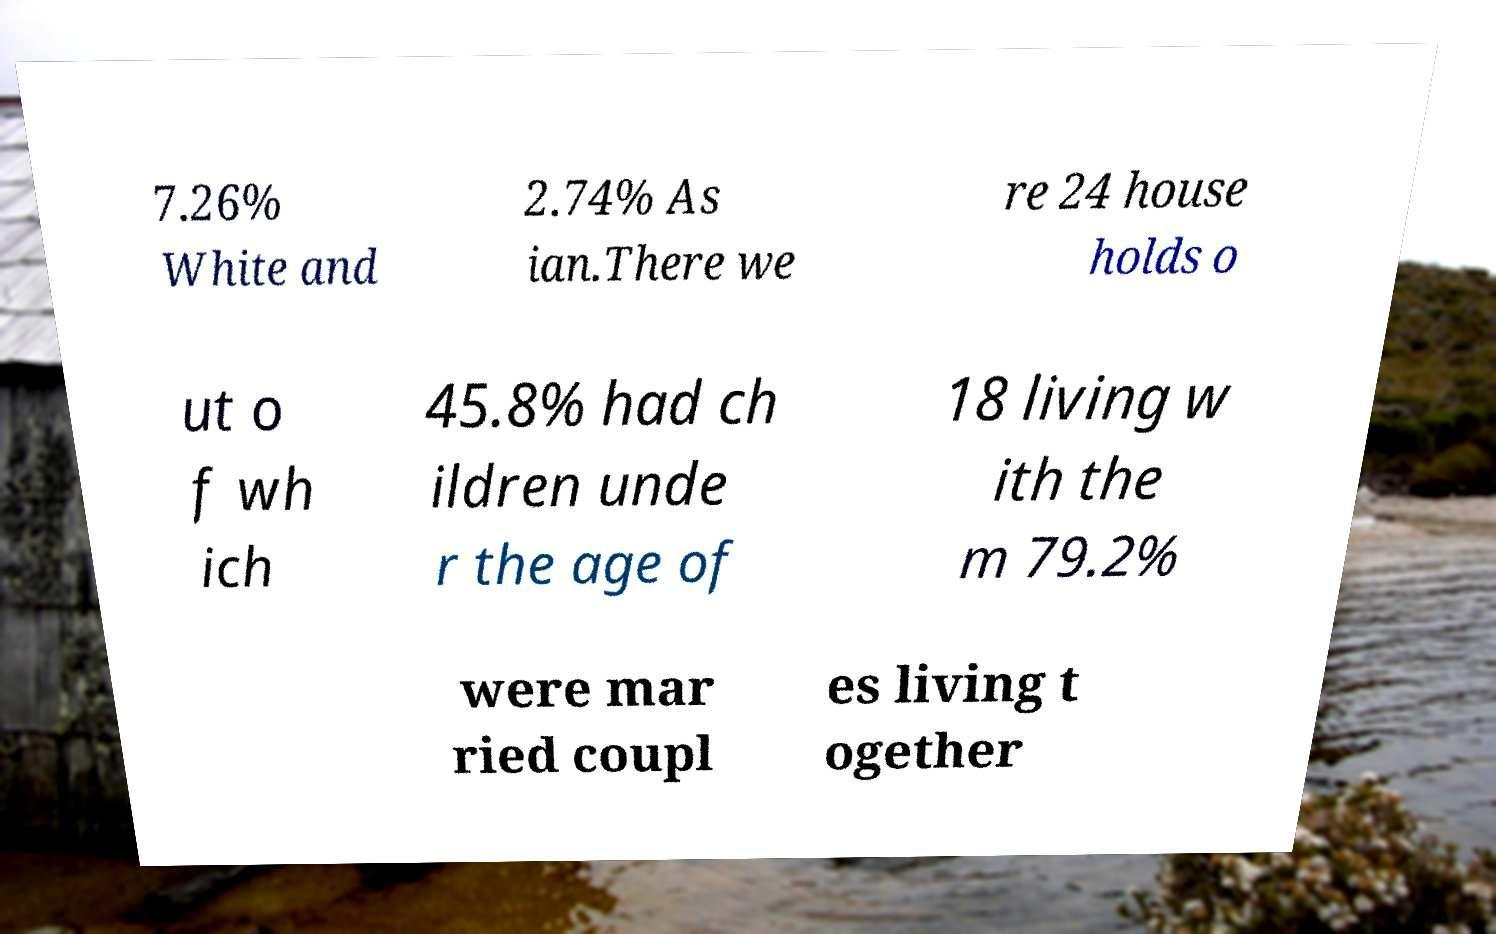What messages or text are displayed in this image? I need them in a readable, typed format. 7.26% White and 2.74% As ian.There we re 24 house holds o ut o f wh ich 45.8% had ch ildren unde r the age of 18 living w ith the m 79.2% were mar ried coupl es living t ogether 